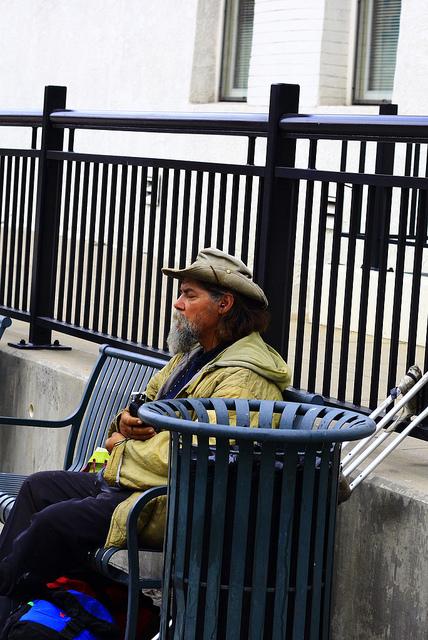What is next to the man?
Answer briefly. Trash can. Is the man homeless?
Be succinct. Yes. Does the man have facial hair?
Concise answer only. Yes. 